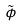Convert formula to latex. <formula><loc_0><loc_0><loc_500><loc_500>\tilde { \phi }</formula> 